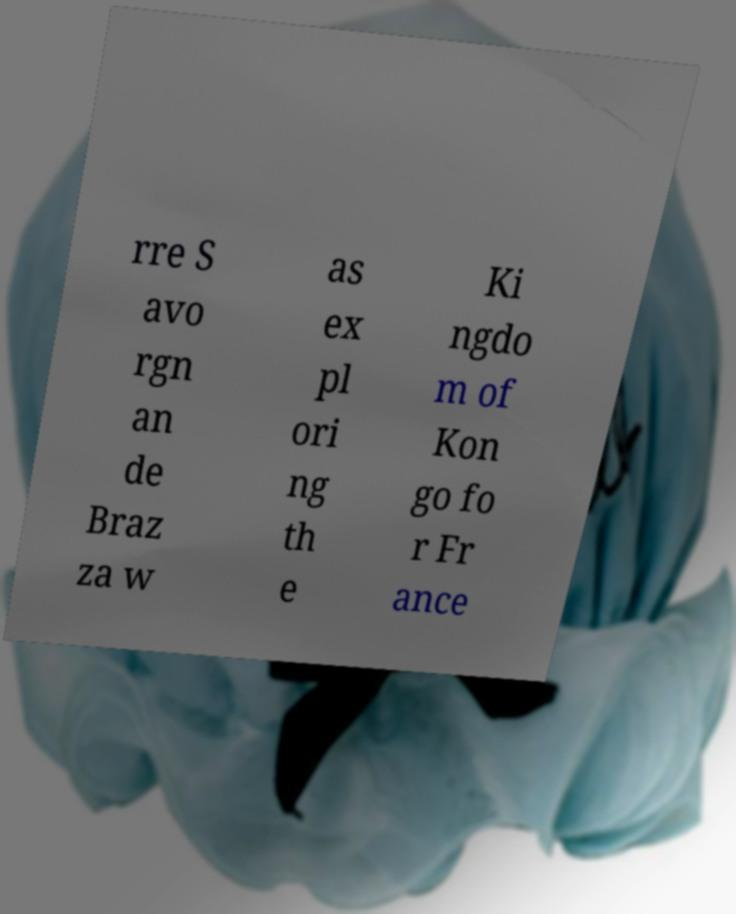Could you assist in decoding the text presented in this image and type it out clearly? rre S avo rgn an de Braz za w as ex pl ori ng th e Ki ngdo m of Kon go fo r Fr ance 